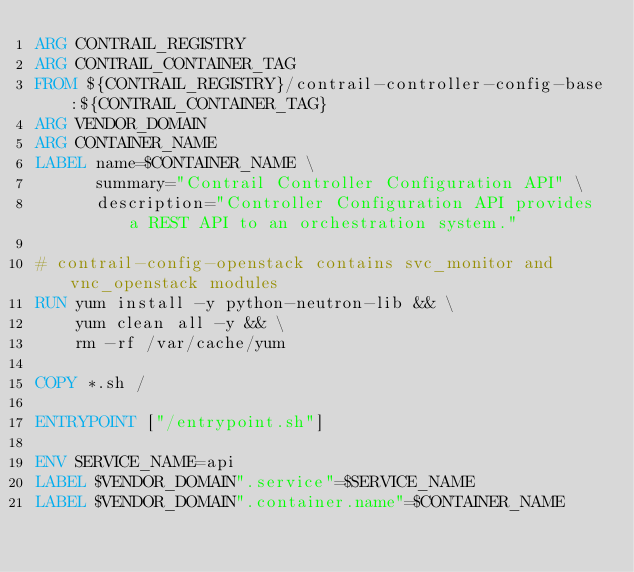Convert code to text. <code><loc_0><loc_0><loc_500><loc_500><_Dockerfile_>ARG CONTRAIL_REGISTRY
ARG CONTRAIL_CONTAINER_TAG
FROM ${CONTRAIL_REGISTRY}/contrail-controller-config-base:${CONTRAIL_CONTAINER_TAG}
ARG VENDOR_DOMAIN
ARG CONTAINER_NAME
LABEL name=$CONTAINER_NAME \
      summary="Contrail Controller Configuration API" \
      description="Controller Configuration API provides a REST API to an orchestration system."

# contrail-config-openstack contains svc_monitor and vnc_openstack modules
RUN yum install -y python-neutron-lib && \
    yum clean all -y && \
    rm -rf /var/cache/yum

COPY *.sh /

ENTRYPOINT ["/entrypoint.sh"]

ENV SERVICE_NAME=api
LABEL $VENDOR_DOMAIN".service"=$SERVICE_NAME
LABEL $VENDOR_DOMAIN".container.name"=$CONTAINER_NAME</code> 